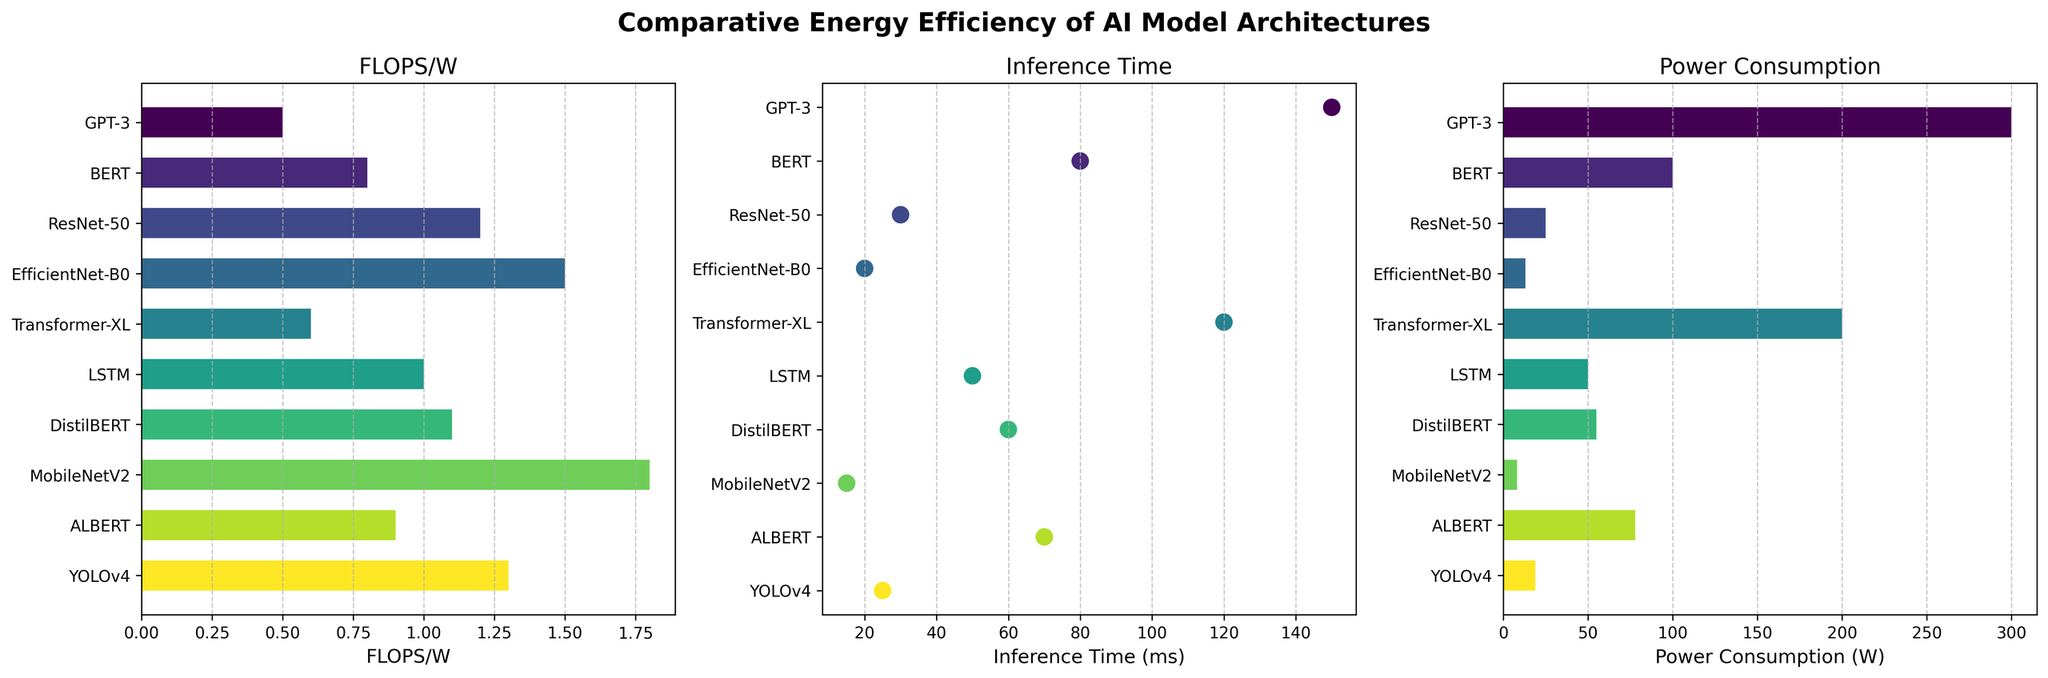What is the title of the entire figure? The title of the entire figure is displayed at the top and is clear and bold. It is "Comparative Energy Efficiency of AI Model Architectures".
Answer: Comparative Energy Efficiency of AI Model Architectures Which AI model has the highest FLOPS/W value? By examining the FLOPS/W plot, the AI model with the highest FLOPS/W bar is identified. MobileNetV2 has the highest bar at the value of 1.8 FLOPS/W.
Answer: MobileNetV2 How does the FLOPS/W of BERT compare to that of YOLOv4? BERT has a FLOPS/W value of 0.8 while YOLOv4 has a FLOPS/W value of 1.3. Comparing these values, YOLOv4 has a higher FLOPS/W than BERT.
Answer: YOLOv4 has a higher FLOPS/W What’s the median value of inference times across all models? The inference times, in ascending order, are 15, 20, 25, 30, 50, 60, 70, 80, 120, 150 ms. The median is the average of the 5th and 6th values: (50 + 60) / 2 = 55 ms.
Answer: 55 ms Which model has the lowest power consumption? By inspecting the Power Consumption plot, the model with the smallest bar is identified. MobileNetV2 has the lowest power consumption at 8 watts.
Answer: MobileNetV2 Compare the power consumption of GPT-3 to Transformer-XL. From the Power Consumption plot, GPT-3 consumes 300 watts and Transformer-XL consumes 200 watts. Therefore, GPT-3 has a higher power consumption than Transformer-XL.
Answer: GPT-3 consumes more power Which models have FLOPS/W greater than 1? By examining the FLOPS/W plot, models with values greater than 1 are identified. They are ResNet-50, EfficientNet-B0, LSTM, DistilBERT, MobileNetV2, and YOLOv4.
Answer: ResNet-50, EfficientNet-B0, LSTM, DistilBERT, MobileNetV2, YOLOv4 What is the average power consumption across all models? The power consumptions are 300, 100, 25, 13, 200, 50, 55, 8, 78, 19 watts. Sum them up to get 848. By dividing by the number of models (10), the average power consumption is 848/10 = 84.8 watts.
Answer: 84.8 watts Which model has the shortest inference time? By checking the Inference Time plot, the model with the lowest data point is identified. MobileNetV2 has the shortest inference time of 15 ms.
Answer: MobileNetV2 